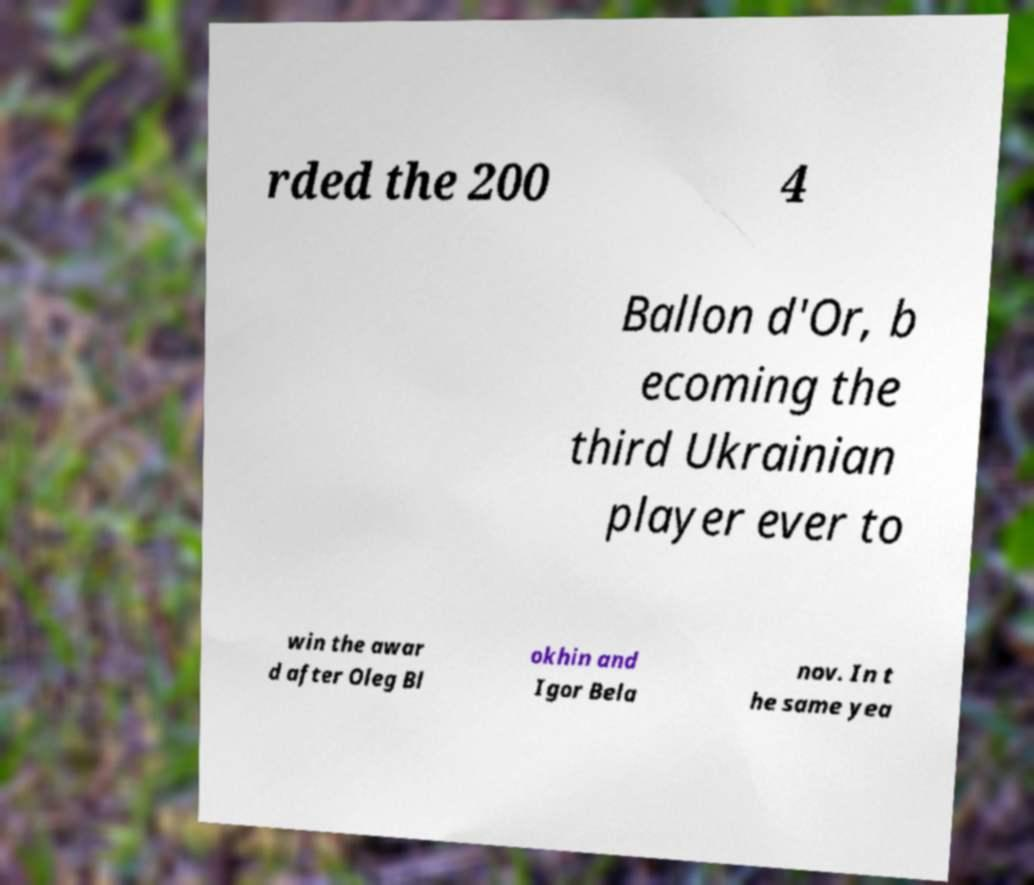There's text embedded in this image that I need extracted. Can you transcribe it verbatim? rded the 200 4 Ballon d'Or, b ecoming the third Ukrainian player ever to win the awar d after Oleg Bl okhin and Igor Bela nov. In t he same yea 